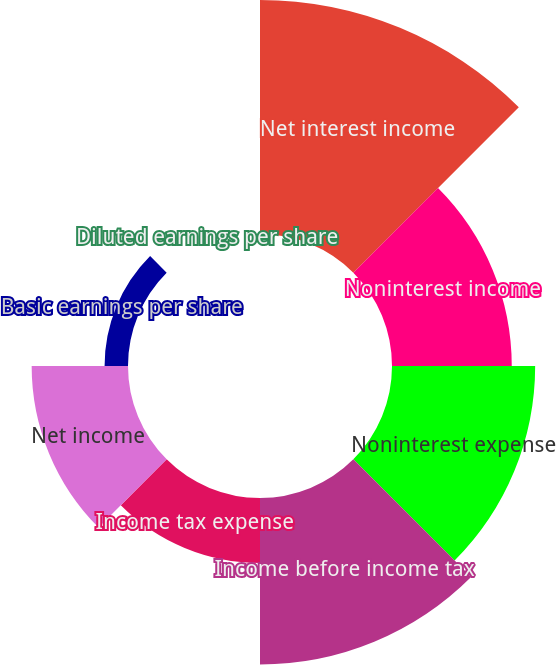Convert chart to OTSL. <chart><loc_0><loc_0><loc_500><loc_500><pie_chart><fcel>Net interest income<fcel>Noninterest income<fcel>Noninterest expense<fcel>Income before income tax<fcel>Income tax expense<fcel>Net income<fcel>Basic earnings per share<fcel>Diluted earnings per share<nl><fcel>27.59%<fcel>14.12%<fcel>16.88%<fcel>19.64%<fcel>7.65%<fcel>11.36%<fcel>2.76%<fcel>0.0%<nl></chart> 